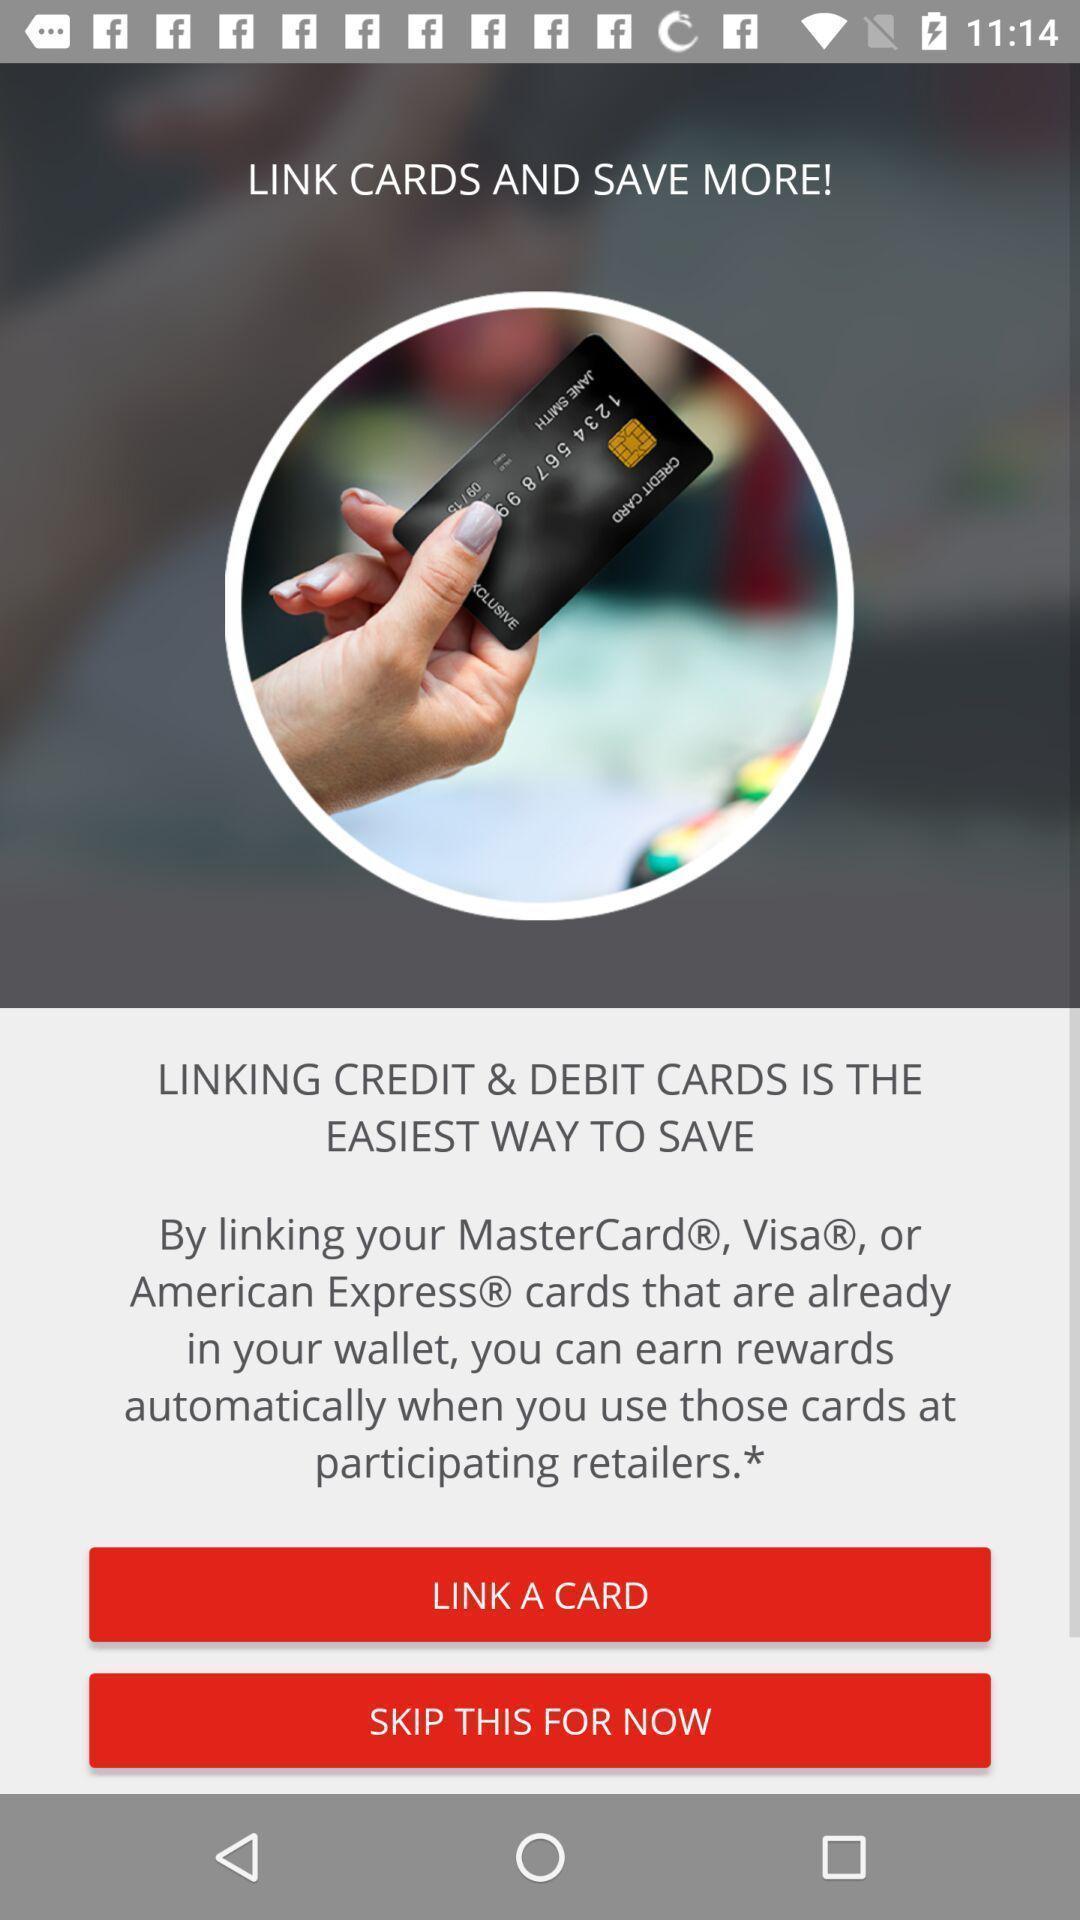Summarize the information in this screenshot. Page showing options to link a card. 